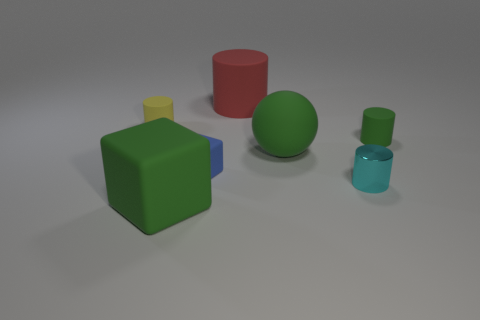Subtract all green matte cylinders. How many cylinders are left? 3 Subtract all yellow cylinders. How many cylinders are left? 3 Subtract 1 cylinders. How many cylinders are left? 3 Add 1 blue rubber things. How many objects exist? 8 Subtract all blocks. How many objects are left? 5 Subtract all yellow cylinders. Subtract all purple cubes. How many cylinders are left? 3 Add 4 cyan cylinders. How many cyan cylinders are left? 5 Add 5 blue spheres. How many blue spheres exist? 5 Subtract 1 blue blocks. How many objects are left? 6 Subtract all tiny cyan metal balls. Subtract all green rubber spheres. How many objects are left? 6 